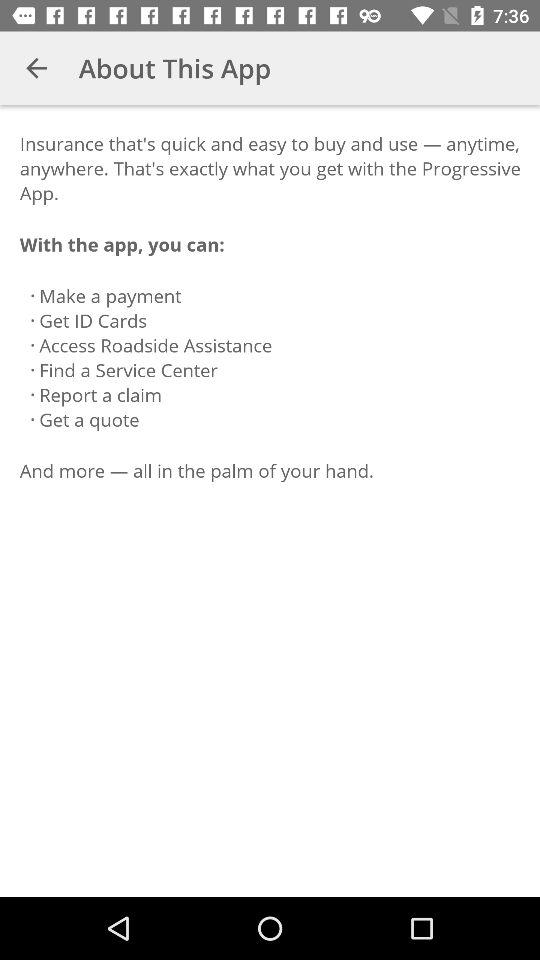How many actions can be performed with the app?
Answer the question using a single word or phrase. 6 